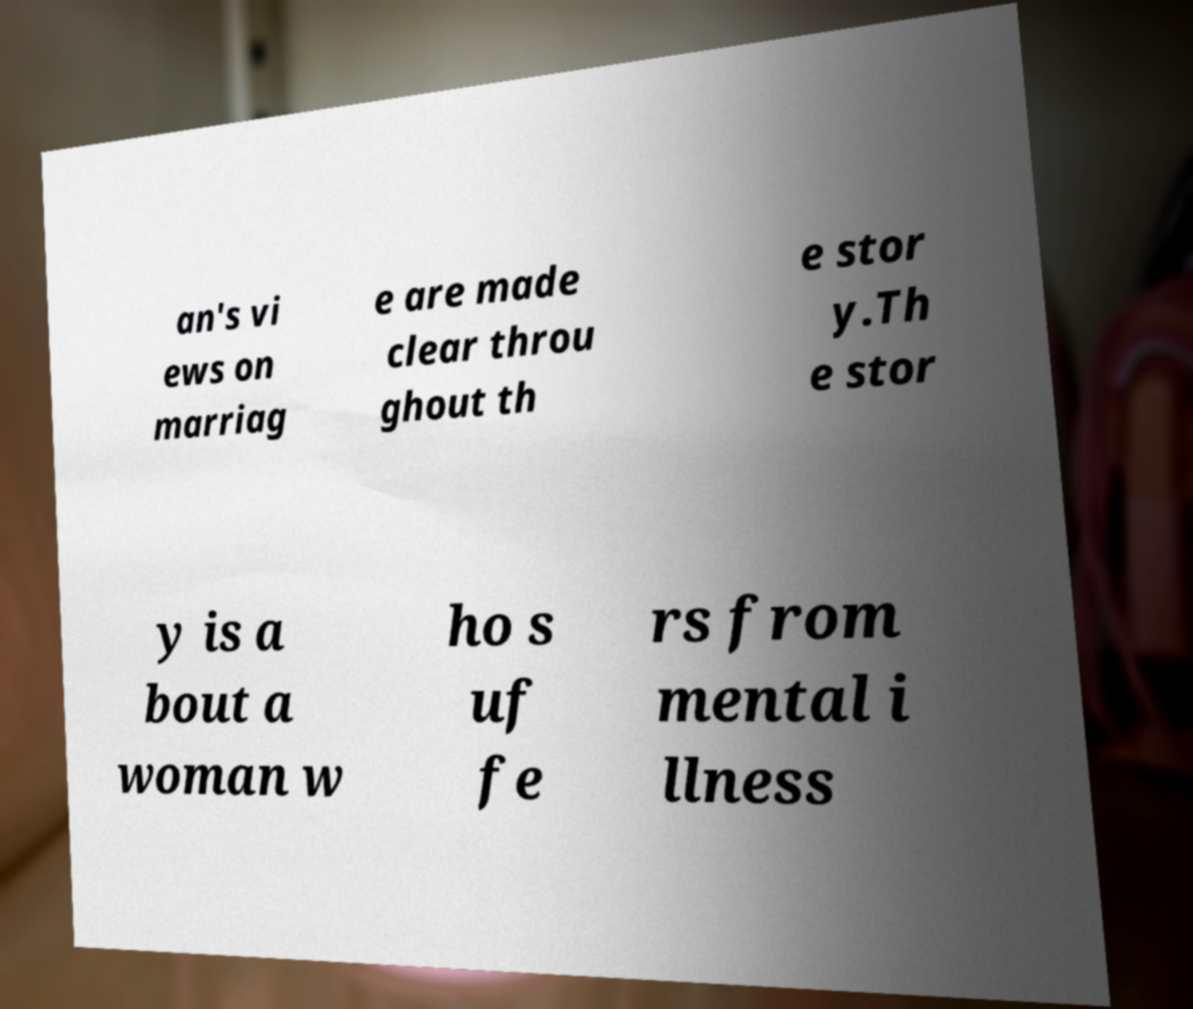I need the written content from this picture converted into text. Can you do that? an's vi ews on marriag e are made clear throu ghout th e stor y.Th e stor y is a bout a woman w ho s uf fe rs from mental i llness 